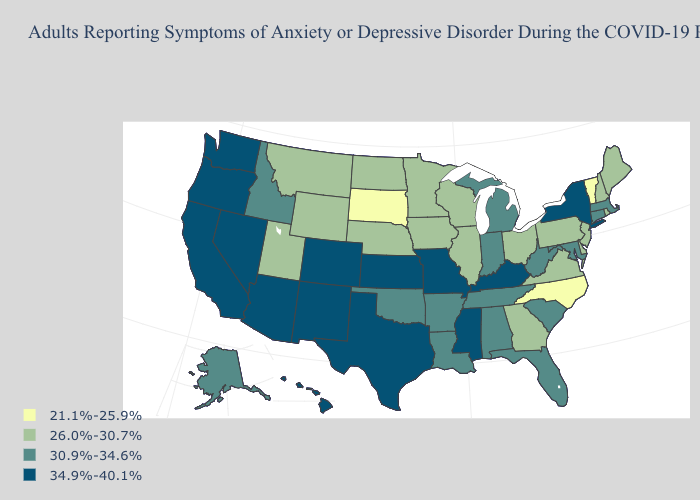What is the value of Pennsylvania?
Give a very brief answer. 26.0%-30.7%. Does New York have the same value as Montana?
Quick response, please. No. What is the value of Tennessee?
Keep it brief. 30.9%-34.6%. Name the states that have a value in the range 34.9%-40.1%?
Short answer required. Arizona, California, Colorado, Hawaii, Kansas, Kentucky, Mississippi, Missouri, Nevada, New Mexico, New York, Oregon, Texas, Washington. How many symbols are there in the legend?
Write a very short answer. 4. What is the value of Kansas?
Write a very short answer. 34.9%-40.1%. Does the first symbol in the legend represent the smallest category?
Short answer required. Yes. What is the value of New Mexico?
Concise answer only. 34.9%-40.1%. What is the lowest value in the USA?
Concise answer only. 21.1%-25.9%. Among the states that border Montana , which have the lowest value?
Answer briefly. South Dakota. What is the value of Massachusetts?
Keep it brief. 30.9%-34.6%. Does the first symbol in the legend represent the smallest category?
Give a very brief answer. Yes. Name the states that have a value in the range 34.9%-40.1%?
Concise answer only. Arizona, California, Colorado, Hawaii, Kansas, Kentucky, Mississippi, Missouri, Nevada, New Mexico, New York, Oregon, Texas, Washington. Is the legend a continuous bar?
Write a very short answer. No. 